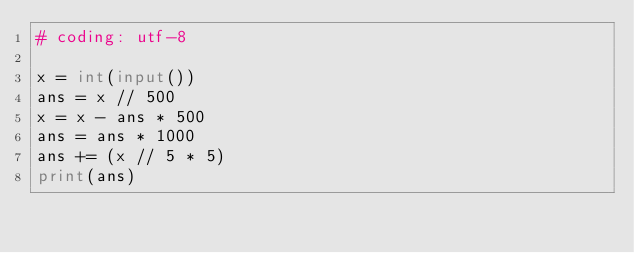<code> <loc_0><loc_0><loc_500><loc_500><_Python_># coding: utf-8

x = int(input())
ans = x // 500
x = x - ans * 500
ans = ans * 1000
ans += (x // 5 * 5)
print(ans)</code> 